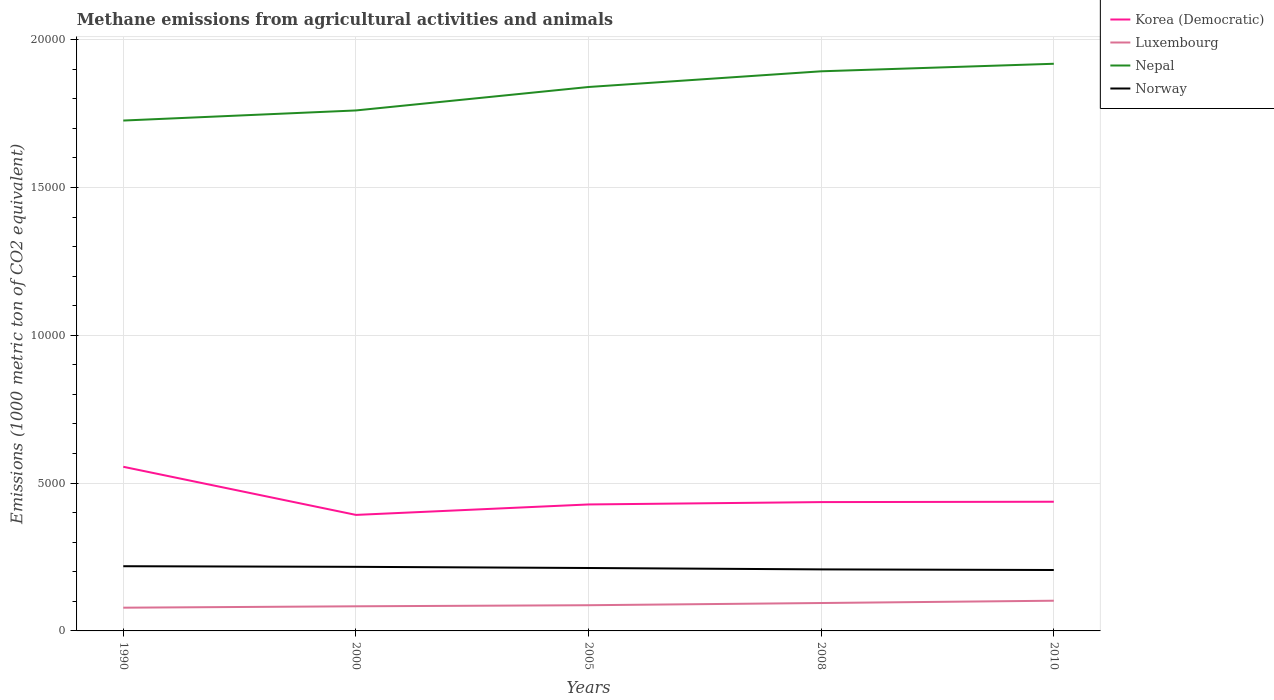Is the number of lines equal to the number of legend labels?
Provide a short and direct response. Yes. Across all years, what is the maximum amount of methane emitted in Norway?
Your answer should be compact. 2060.5. In which year was the amount of methane emitted in Nepal maximum?
Your response must be concise. 1990. What is the total amount of methane emitted in Norway in the graph?
Offer a very short reply. 39.3. What is the difference between the highest and the second highest amount of methane emitted in Norway?
Provide a short and direct response. 128. Is the amount of methane emitted in Luxembourg strictly greater than the amount of methane emitted in Nepal over the years?
Offer a terse response. Yes. What is the difference between two consecutive major ticks on the Y-axis?
Ensure brevity in your answer.  5000. Does the graph contain grids?
Provide a short and direct response. Yes. Where does the legend appear in the graph?
Your response must be concise. Top right. How are the legend labels stacked?
Provide a succinct answer. Vertical. What is the title of the graph?
Your answer should be very brief. Methane emissions from agricultural activities and animals. What is the label or title of the X-axis?
Offer a terse response. Years. What is the label or title of the Y-axis?
Provide a short and direct response. Emissions (1000 metric ton of CO2 equivalent). What is the Emissions (1000 metric ton of CO2 equivalent) of Korea (Democratic) in 1990?
Offer a terse response. 5552.4. What is the Emissions (1000 metric ton of CO2 equivalent) in Luxembourg in 1990?
Make the answer very short. 785.7. What is the Emissions (1000 metric ton of CO2 equivalent) in Nepal in 1990?
Provide a short and direct response. 1.73e+04. What is the Emissions (1000 metric ton of CO2 equivalent) of Norway in 1990?
Your response must be concise. 2188.5. What is the Emissions (1000 metric ton of CO2 equivalent) in Korea (Democratic) in 2000?
Keep it short and to the point. 3924.5. What is the Emissions (1000 metric ton of CO2 equivalent) of Luxembourg in 2000?
Make the answer very short. 832.7. What is the Emissions (1000 metric ton of CO2 equivalent) of Nepal in 2000?
Offer a terse response. 1.76e+04. What is the Emissions (1000 metric ton of CO2 equivalent) in Norway in 2000?
Provide a short and direct response. 2167.9. What is the Emissions (1000 metric ton of CO2 equivalent) of Korea (Democratic) in 2005?
Your answer should be very brief. 4277.9. What is the Emissions (1000 metric ton of CO2 equivalent) of Luxembourg in 2005?
Provide a succinct answer. 869.4. What is the Emissions (1000 metric ton of CO2 equivalent) of Nepal in 2005?
Ensure brevity in your answer.  1.84e+04. What is the Emissions (1000 metric ton of CO2 equivalent) in Norway in 2005?
Offer a very short reply. 2128.6. What is the Emissions (1000 metric ton of CO2 equivalent) of Korea (Democratic) in 2008?
Give a very brief answer. 4357.8. What is the Emissions (1000 metric ton of CO2 equivalent) of Luxembourg in 2008?
Provide a short and direct response. 943.9. What is the Emissions (1000 metric ton of CO2 equivalent) in Nepal in 2008?
Your response must be concise. 1.89e+04. What is the Emissions (1000 metric ton of CO2 equivalent) of Norway in 2008?
Keep it short and to the point. 2081.3. What is the Emissions (1000 metric ton of CO2 equivalent) in Korea (Democratic) in 2010?
Provide a short and direct response. 4370.1. What is the Emissions (1000 metric ton of CO2 equivalent) in Luxembourg in 2010?
Your answer should be very brief. 1021.4. What is the Emissions (1000 metric ton of CO2 equivalent) of Nepal in 2010?
Your answer should be very brief. 1.92e+04. What is the Emissions (1000 metric ton of CO2 equivalent) of Norway in 2010?
Provide a short and direct response. 2060.5. Across all years, what is the maximum Emissions (1000 metric ton of CO2 equivalent) in Korea (Democratic)?
Provide a succinct answer. 5552.4. Across all years, what is the maximum Emissions (1000 metric ton of CO2 equivalent) of Luxembourg?
Offer a terse response. 1021.4. Across all years, what is the maximum Emissions (1000 metric ton of CO2 equivalent) of Nepal?
Ensure brevity in your answer.  1.92e+04. Across all years, what is the maximum Emissions (1000 metric ton of CO2 equivalent) of Norway?
Make the answer very short. 2188.5. Across all years, what is the minimum Emissions (1000 metric ton of CO2 equivalent) of Korea (Democratic)?
Keep it short and to the point. 3924.5. Across all years, what is the minimum Emissions (1000 metric ton of CO2 equivalent) of Luxembourg?
Make the answer very short. 785.7. Across all years, what is the minimum Emissions (1000 metric ton of CO2 equivalent) of Nepal?
Your answer should be very brief. 1.73e+04. Across all years, what is the minimum Emissions (1000 metric ton of CO2 equivalent) in Norway?
Offer a very short reply. 2060.5. What is the total Emissions (1000 metric ton of CO2 equivalent) in Korea (Democratic) in the graph?
Your answer should be very brief. 2.25e+04. What is the total Emissions (1000 metric ton of CO2 equivalent) in Luxembourg in the graph?
Provide a short and direct response. 4453.1. What is the total Emissions (1000 metric ton of CO2 equivalent) of Nepal in the graph?
Your answer should be very brief. 9.14e+04. What is the total Emissions (1000 metric ton of CO2 equivalent) of Norway in the graph?
Offer a very short reply. 1.06e+04. What is the difference between the Emissions (1000 metric ton of CO2 equivalent) of Korea (Democratic) in 1990 and that in 2000?
Offer a terse response. 1627.9. What is the difference between the Emissions (1000 metric ton of CO2 equivalent) in Luxembourg in 1990 and that in 2000?
Provide a short and direct response. -47. What is the difference between the Emissions (1000 metric ton of CO2 equivalent) in Nepal in 1990 and that in 2000?
Provide a short and direct response. -341.8. What is the difference between the Emissions (1000 metric ton of CO2 equivalent) in Norway in 1990 and that in 2000?
Offer a very short reply. 20.6. What is the difference between the Emissions (1000 metric ton of CO2 equivalent) in Korea (Democratic) in 1990 and that in 2005?
Offer a terse response. 1274.5. What is the difference between the Emissions (1000 metric ton of CO2 equivalent) in Luxembourg in 1990 and that in 2005?
Offer a terse response. -83.7. What is the difference between the Emissions (1000 metric ton of CO2 equivalent) of Nepal in 1990 and that in 2005?
Provide a short and direct response. -1135.1. What is the difference between the Emissions (1000 metric ton of CO2 equivalent) of Norway in 1990 and that in 2005?
Your answer should be very brief. 59.9. What is the difference between the Emissions (1000 metric ton of CO2 equivalent) of Korea (Democratic) in 1990 and that in 2008?
Offer a very short reply. 1194.6. What is the difference between the Emissions (1000 metric ton of CO2 equivalent) of Luxembourg in 1990 and that in 2008?
Ensure brevity in your answer.  -158.2. What is the difference between the Emissions (1000 metric ton of CO2 equivalent) in Nepal in 1990 and that in 2008?
Provide a short and direct response. -1666.2. What is the difference between the Emissions (1000 metric ton of CO2 equivalent) of Norway in 1990 and that in 2008?
Offer a terse response. 107.2. What is the difference between the Emissions (1000 metric ton of CO2 equivalent) of Korea (Democratic) in 1990 and that in 2010?
Make the answer very short. 1182.3. What is the difference between the Emissions (1000 metric ton of CO2 equivalent) in Luxembourg in 1990 and that in 2010?
Ensure brevity in your answer.  -235.7. What is the difference between the Emissions (1000 metric ton of CO2 equivalent) in Nepal in 1990 and that in 2010?
Your response must be concise. -1920.6. What is the difference between the Emissions (1000 metric ton of CO2 equivalent) of Norway in 1990 and that in 2010?
Offer a very short reply. 128. What is the difference between the Emissions (1000 metric ton of CO2 equivalent) in Korea (Democratic) in 2000 and that in 2005?
Give a very brief answer. -353.4. What is the difference between the Emissions (1000 metric ton of CO2 equivalent) of Luxembourg in 2000 and that in 2005?
Your response must be concise. -36.7. What is the difference between the Emissions (1000 metric ton of CO2 equivalent) of Nepal in 2000 and that in 2005?
Provide a short and direct response. -793.3. What is the difference between the Emissions (1000 metric ton of CO2 equivalent) of Norway in 2000 and that in 2005?
Offer a terse response. 39.3. What is the difference between the Emissions (1000 metric ton of CO2 equivalent) in Korea (Democratic) in 2000 and that in 2008?
Ensure brevity in your answer.  -433.3. What is the difference between the Emissions (1000 metric ton of CO2 equivalent) in Luxembourg in 2000 and that in 2008?
Your answer should be very brief. -111.2. What is the difference between the Emissions (1000 metric ton of CO2 equivalent) in Nepal in 2000 and that in 2008?
Your response must be concise. -1324.4. What is the difference between the Emissions (1000 metric ton of CO2 equivalent) in Norway in 2000 and that in 2008?
Provide a short and direct response. 86.6. What is the difference between the Emissions (1000 metric ton of CO2 equivalent) in Korea (Democratic) in 2000 and that in 2010?
Ensure brevity in your answer.  -445.6. What is the difference between the Emissions (1000 metric ton of CO2 equivalent) in Luxembourg in 2000 and that in 2010?
Offer a very short reply. -188.7. What is the difference between the Emissions (1000 metric ton of CO2 equivalent) of Nepal in 2000 and that in 2010?
Provide a short and direct response. -1578.8. What is the difference between the Emissions (1000 metric ton of CO2 equivalent) in Norway in 2000 and that in 2010?
Make the answer very short. 107.4. What is the difference between the Emissions (1000 metric ton of CO2 equivalent) of Korea (Democratic) in 2005 and that in 2008?
Your answer should be compact. -79.9. What is the difference between the Emissions (1000 metric ton of CO2 equivalent) in Luxembourg in 2005 and that in 2008?
Keep it short and to the point. -74.5. What is the difference between the Emissions (1000 metric ton of CO2 equivalent) in Nepal in 2005 and that in 2008?
Offer a terse response. -531.1. What is the difference between the Emissions (1000 metric ton of CO2 equivalent) in Norway in 2005 and that in 2008?
Provide a short and direct response. 47.3. What is the difference between the Emissions (1000 metric ton of CO2 equivalent) in Korea (Democratic) in 2005 and that in 2010?
Offer a very short reply. -92.2. What is the difference between the Emissions (1000 metric ton of CO2 equivalent) in Luxembourg in 2005 and that in 2010?
Your response must be concise. -152. What is the difference between the Emissions (1000 metric ton of CO2 equivalent) in Nepal in 2005 and that in 2010?
Provide a succinct answer. -785.5. What is the difference between the Emissions (1000 metric ton of CO2 equivalent) of Norway in 2005 and that in 2010?
Offer a very short reply. 68.1. What is the difference between the Emissions (1000 metric ton of CO2 equivalent) of Luxembourg in 2008 and that in 2010?
Offer a very short reply. -77.5. What is the difference between the Emissions (1000 metric ton of CO2 equivalent) in Nepal in 2008 and that in 2010?
Give a very brief answer. -254.4. What is the difference between the Emissions (1000 metric ton of CO2 equivalent) in Norway in 2008 and that in 2010?
Your answer should be compact. 20.8. What is the difference between the Emissions (1000 metric ton of CO2 equivalent) of Korea (Democratic) in 1990 and the Emissions (1000 metric ton of CO2 equivalent) of Luxembourg in 2000?
Keep it short and to the point. 4719.7. What is the difference between the Emissions (1000 metric ton of CO2 equivalent) in Korea (Democratic) in 1990 and the Emissions (1000 metric ton of CO2 equivalent) in Nepal in 2000?
Your answer should be compact. -1.21e+04. What is the difference between the Emissions (1000 metric ton of CO2 equivalent) of Korea (Democratic) in 1990 and the Emissions (1000 metric ton of CO2 equivalent) of Norway in 2000?
Make the answer very short. 3384.5. What is the difference between the Emissions (1000 metric ton of CO2 equivalent) in Luxembourg in 1990 and the Emissions (1000 metric ton of CO2 equivalent) in Nepal in 2000?
Make the answer very short. -1.68e+04. What is the difference between the Emissions (1000 metric ton of CO2 equivalent) of Luxembourg in 1990 and the Emissions (1000 metric ton of CO2 equivalent) of Norway in 2000?
Offer a very short reply. -1382.2. What is the difference between the Emissions (1000 metric ton of CO2 equivalent) in Nepal in 1990 and the Emissions (1000 metric ton of CO2 equivalent) in Norway in 2000?
Offer a very short reply. 1.51e+04. What is the difference between the Emissions (1000 metric ton of CO2 equivalent) in Korea (Democratic) in 1990 and the Emissions (1000 metric ton of CO2 equivalent) in Luxembourg in 2005?
Ensure brevity in your answer.  4683. What is the difference between the Emissions (1000 metric ton of CO2 equivalent) in Korea (Democratic) in 1990 and the Emissions (1000 metric ton of CO2 equivalent) in Nepal in 2005?
Your response must be concise. -1.28e+04. What is the difference between the Emissions (1000 metric ton of CO2 equivalent) in Korea (Democratic) in 1990 and the Emissions (1000 metric ton of CO2 equivalent) in Norway in 2005?
Your answer should be very brief. 3423.8. What is the difference between the Emissions (1000 metric ton of CO2 equivalent) of Luxembourg in 1990 and the Emissions (1000 metric ton of CO2 equivalent) of Nepal in 2005?
Your answer should be compact. -1.76e+04. What is the difference between the Emissions (1000 metric ton of CO2 equivalent) in Luxembourg in 1990 and the Emissions (1000 metric ton of CO2 equivalent) in Norway in 2005?
Your response must be concise. -1342.9. What is the difference between the Emissions (1000 metric ton of CO2 equivalent) of Nepal in 1990 and the Emissions (1000 metric ton of CO2 equivalent) of Norway in 2005?
Your response must be concise. 1.51e+04. What is the difference between the Emissions (1000 metric ton of CO2 equivalent) of Korea (Democratic) in 1990 and the Emissions (1000 metric ton of CO2 equivalent) of Luxembourg in 2008?
Provide a succinct answer. 4608.5. What is the difference between the Emissions (1000 metric ton of CO2 equivalent) in Korea (Democratic) in 1990 and the Emissions (1000 metric ton of CO2 equivalent) in Nepal in 2008?
Make the answer very short. -1.34e+04. What is the difference between the Emissions (1000 metric ton of CO2 equivalent) of Korea (Democratic) in 1990 and the Emissions (1000 metric ton of CO2 equivalent) of Norway in 2008?
Offer a terse response. 3471.1. What is the difference between the Emissions (1000 metric ton of CO2 equivalent) in Luxembourg in 1990 and the Emissions (1000 metric ton of CO2 equivalent) in Nepal in 2008?
Provide a short and direct response. -1.81e+04. What is the difference between the Emissions (1000 metric ton of CO2 equivalent) in Luxembourg in 1990 and the Emissions (1000 metric ton of CO2 equivalent) in Norway in 2008?
Your answer should be very brief. -1295.6. What is the difference between the Emissions (1000 metric ton of CO2 equivalent) of Nepal in 1990 and the Emissions (1000 metric ton of CO2 equivalent) of Norway in 2008?
Make the answer very short. 1.52e+04. What is the difference between the Emissions (1000 metric ton of CO2 equivalent) of Korea (Democratic) in 1990 and the Emissions (1000 metric ton of CO2 equivalent) of Luxembourg in 2010?
Keep it short and to the point. 4531. What is the difference between the Emissions (1000 metric ton of CO2 equivalent) in Korea (Democratic) in 1990 and the Emissions (1000 metric ton of CO2 equivalent) in Nepal in 2010?
Offer a very short reply. -1.36e+04. What is the difference between the Emissions (1000 metric ton of CO2 equivalent) of Korea (Democratic) in 1990 and the Emissions (1000 metric ton of CO2 equivalent) of Norway in 2010?
Ensure brevity in your answer.  3491.9. What is the difference between the Emissions (1000 metric ton of CO2 equivalent) of Luxembourg in 1990 and the Emissions (1000 metric ton of CO2 equivalent) of Nepal in 2010?
Provide a succinct answer. -1.84e+04. What is the difference between the Emissions (1000 metric ton of CO2 equivalent) of Luxembourg in 1990 and the Emissions (1000 metric ton of CO2 equivalent) of Norway in 2010?
Offer a terse response. -1274.8. What is the difference between the Emissions (1000 metric ton of CO2 equivalent) of Nepal in 1990 and the Emissions (1000 metric ton of CO2 equivalent) of Norway in 2010?
Give a very brief answer. 1.52e+04. What is the difference between the Emissions (1000 metric ton of CO2 equivalent) in Korea (Democratic) in 2000 and the Emissions (1000 metric ton of CO2 equivalent) in Luxembourg in 2005?
Your answer should be compact. 3055.1. What is the difference between the Emissions (1000 metric ton of CO2 equivalent) of Korea (Democratic) in 2000 and the Emissions (1000 metric ton of CO2 equivalent) of Nepal in 2005?
Make the answer very short. -1.45e+04. What is the difference between the Emissions (1000 metric ton of CO2 equivalent) in Korea (Democratic) in 2000 and the Emissions (1000 metric ton of CO2 equivalent) in Norway in 2005?
Your response must be concise. 1795.9. What is the difference between the Emissions (1000 metric ton of CO2 equivalent) in Luxembourg in 2000 and the Emissions (1000 metric ton of CO2 equivalent) in Nepal in 2005?
Your answer should be compact. -1.76e+04. What is the difference between the Emissions (1000 metric ton of CO2 equivalent) of Luxembourg in 2000 and the Emissions (1000 metric ton of CO2 equivalent) of Norway in 2005?
Your answer should be very brief. -1295.9. What is the difference between the Emissions (1000 metric ton of CO2 equivalent) in Nepal in 2000 and the Emissions (1000 metric ton of CO2 equivalent) in Norway in 2005?
Offer a very short reply. 1.55e+04. What is the difference between the Emissions (1000 metric ton of CO2 equivalent) of Korea (Democratic) in 2000 and the Emissions (1000 metric ton of CO2 equivalent) of Luxembourg in 2008?
Ensure brevity in your answer.  2980.6. What is the difference between the Emissions (1000 metric ton of CO2 equivalent) of Korea (Democratic) in 2000 and the Emissions (1000 metric ton of CO2 equivalent) of Nepal in 2008?
Your answer should be compact. -1.50e+04. What is the difference between the Emissions (1000 metric ton of CO2 equivalent) of Korea (Democratic) in 2000 and the Emissions (1000 metric ton of CO2 equivalent) of Norway in 2008?
Offer a terse response. 1843.2. What is the difference between the Emissions (1000 metric ton of CO2 equivalent) in Luxembourg in 2000 and the Emissions (1000 metric ton of CO2 equivalent) in Nepal in 2008?
Give a very brief answer. -1.81e+04. What is the difference between the Emissions (1000 metric ton of CO2 equivalent) in Luxembourg in 2000 and the Emissions (1000 metric ton of CO2 equivalent) in Norway in 2008?
Offer a terse response. -1248.6. What is the difference between the Emissions (1000 metric ton of CO2 equivalent) in Nepal in 2000 and the Emissions (1000 metric ton of CO2 equivalent) in Norway in 2008?
Keep it short and to the point. 1.55e+04. What is the difference between the Emissions (1000 metric ton of CO2 equivalent) in Korea (Democratic) in 2000 and the Emissions (1000 metric ton of CO2 equivalent) in Luxembourg in 2010?
Provide a succinct answer. 2903.1. What is the difference between the Emissions (1000 metric ton of CO2 equivalent) in Korea (Democratic) in 2000 and the Emissions (1000 metric ton of CO2 equivalent) in Nepal in 2010?
Keep it short and to the point. -1.53e+04. What is the difference between the Emissions (1000 metric ton of CO2 equivalent) in Korea (Democratic) in 2000 and the Emissions (1000 metric ton of CO2 equivalent) in Norway in 2010?
Offer a terse response. 1864. What is the difference between the Emissions (1000 metric ton of CO2 equivalent) in Luxembourg in 2000 and the Emissions (1000 metric ton of CO2 equivalent) in Nepal in 2010?
Offer a terse response. -1.84e+04. What is the difference between the Emissions (1000 metric ton of CO2 equivalent) in Luxembourg in 2000 and the Emissions (1000 metric ton of CO2 equivalent) in Norway in 2010?
Provide a short and direct response. -1227.8. What is the difference between the Emissions (1000 metric ton of CO2 equivalent) of Nepal in 2000 and the Emissions (1000 metric ton of CO2 equivalent) of Norway in 2010?
Offer a very short reply. 1.55e+04. What is the difference between the Emissions (1000 metric ton of CO2 equivalent) in Korea (Democratic) in 2005 and the Emissions (1000 metric ton of CO2 equivalent) in Luxembourg in 2008?
Your response must be concise. 3334. What is the difference between the Emissions (1000 metric ton of CO2 equivalent) in Korea (Democratic) in 2005 and the Emissions (1000 metric ton of CO2 equivalent) in Nepal in 2008?
Provide a short and direct response. -1.47e+04. What is the difference between the Emissions (1000 metric ton of CO2 equivalent) in Korea (Democratic) in 2005 and the Emissions (1000 metric ton of CO2 equivalent) in Norway in 2008?
Your answer should be very brief. 2196.6. What is the difference between the Emissions (1000 metric ton of CO2 equivalent) of Luxembourg in 2005 and the Emissions (1000 metric ton of CO2 equivalent) of Nepal in 2008?
Your response must be concise. -1.81e+04. What is the difference between the Emissions (1000 metric ton of CO2 equivalent) in Luxembourg in 2005 and the Emissions (1000 metric ton of CO2 equivalent) in Norway in 2008?
Your response must be concise. -1211.9. What is the difference between the Emissions (1000 metric ton of CO2 equivalent) in Nepal in 2005 and the Emissions (1000 metric ton of CO2 equivalent) in Norway in 2008?
Provide a succinct answer. 1.63e+04. What is the difference between the Emissions (1000 metric ton of CO2 equivalent) in Korea (Democratic) in 2005 and the Emissions (1000 metric ton of CO2 equivalent) in Luxembourg in 2010?
Give a very brief answer. 3256.5. What is the difference between the Emissions (1000 metric ton of CO2 equivalent) in Korea (Democratic) in 2005 and the Emissions (1000 metric ton of CO2 equivalent) in Nepal in 2010?
Your response must be concise. -1.49e+04. What is the difference between the Emissions (1000 metric ton of CO2 equivalent) of Korea (Democratic) in 2005 and the Emissions (1000 metric ton of CO2 equivalent) of Norway in 2010?
Offer a very short reply. 2217.4. What is the difference between the Emissions (1000 metric ton of CO2 equivalent) in Luxembourg in 2005 and the Emissions (1000 metric ton of CO2 equivalent) in Nepal in 2010?
Offer a terse response. -1.83e+04. What is the difference between the Emissions (1000 metric ton of CO2 equivalent) of Luxembourg in 2005 and the Emissions (1000 metric ton of CO2 equivalent) of Norway in 2010?
Your answer should be compact. -1191.1. What is the difference between the Emissions (1000 metric ton of CO2 equivalent) of Nepal in 2005 and the Emissions (1000 metric ton of CO2 equivalent) of Norway in 2010?
Keep it short and to the point. 1.63e+04. What is the difference between the Emissions (1000 metric ton of CO2 equivalent) of Korea (Democratic) in 2008 and the Emissions (1000 metric ton of CO2 equivalent) of Luxembourg in 2010?
Offer a terse response. 3336.4. What is the difference between the Emissions (1000 metric ton of CO2 equivalent) in Korea (Democratic) in 2008 and the Emissions (1000 metric ton of CO2 equivalent) in Nepal in 2010?
Provide a succinct answer. -1.48e+04. What is the difference between the Emissions (1000 metric ton of CO2 equivalent) in Korea (Democratic) in 2008 and the Emissions (1000 metric ton of CO2 equivalent) in Norway in 2010?
Keep it short and to the point. 2297.3. What is the difference between the Emissions (1000 metric ton of CO2 equivalent) in Luxembourg in 2008 and the Emissions (1000 metric ton of CO2 equivalent) in Nepal in 2010?
Offer a very short reply. -1.82e+04. What is the difference between the Emissions (1000 metric ton of CO2 equivalent) in Luxembourg in 2008 and the Emissions (1000 metric ton of CO2 equivalent) in Norway in 2010?
Provide a succinct answer. -1116.6. What is the difference between the Emissions (1000 metric ton of CO2 equivalent) in Nepal in 2008 and the Emissions (1000 metric ton of CO2 equivalent) in Norway in 2010?
Your response must be concise. 1.69e+04. What is the average Emissions (1000 metric ton of CO2 equivalent) in Korea (Democratic) per year?
Keep it short and to the point. 4496.54. What is the average Emissions (1000 metric ton of CO2 equivalent) in Luxembourg per year?
Your answer should be very brief. 890.62. What is the average Emissions (1000 metric ton of CO2 equivalent) of Nepal per year?
Your answer should be compact. 1.83e+04. What is the average Emissions (1000 metric ton of CO2 equivalent) in Norway per year?
Keep it short and to the point. 2125.36. In the year 1990, what is the difference between the Emissions (1000 metric ton of CO2 equivalent) in Korea (Democratic) and Emissions (1000 metric ton of CO2 equivalent) in Luxembourg?
Your answer should be very brief. 4766.7. In the year 1990, what is the difference between the Emissions (1000 metric ton of CO2 equivalent) of Korea (Democratic) and Emissions (1000 metric ton of CO2 equivalent) of Nepal?
Your response must be concise. -1.17e+04. In the year 1990, what is the difference between the Emissions (1000 metric ton of CO2 equivalent) in Korea (Democratic) and Emissions (1000 metric ton of CO2 equivalent) in Norway?
Offer a very short reply. 3363.9. In the year 1990, what is the difference between the Emissions (1000 metric ton of CO2 equivalent) in Luxembourg and Emissions (1000 metric ton of CO2 equivalent) in Nepal?
Keep it short and to the point. -1.65e+04. In the year 1990, what is the difference between the Emissions (1000 metric ton of CO2 equivalent) of Luxembourg and Emissions (1000 metric ton of CO2 equivalent) of Norway?
Offer a terse response. -1402.8. In the year 1990, what is the difference between the Emissions (1000 metric ton of CO2 equivalent) in Nepal and Emissions (1000 metric ton of CO2 equivalent) in Norway?
Make the answer very short. 1.51e+04. In the year 2000, what is the difference between the Emissions (1000 metric ton of CO2 equivalent) in Korea (Democratic) and Emissions (1000 metric ton of CO2 equivalent) in Luxembourg?
Your answer should be compact. 3091.8. In the year 2000, what is the difference between the Emissions (1000 metric ton of CO2 equivalent) of Korea (Democratic) and Emissions (1000 metric ton of CO2 equivalent) of Nepal?
Make the answer very short. -1.37e+04. In the year 2000, what is the difference between the Emissions (1000 metric ton of CO2 equivalent) in Korea (Democratic) and Emissions (1000 metric ton of CO2 equivalent) in Norway?
Offer a terse response. 1756.6. In the year 2000, what is the difference between the Emissions (1000 metric ton of CO2 equivalent) of Luxembourg and Emissions (1000 metric ton of CO2 equivalent) of Nepal?
Provide a succinct answer. -1.68e+04. In the year 2000, what is the difference between the Emissions (1000 metric ton of CO2 equivalent) of Luxembourg and Emissions (1000 metric ton of CO2 equivalent) of Norway?
Ensure brevity in your answer.  -1335.2. In the year 2000, what is the difference between the Emissions (1000 metric ton of CO2 equivalent) in Nepal and Emissions (1000 metric ton of CO2 equivalent) in Norway?
Give a very brief answer. 1.54e+04. In the year 2005, what is the difference between the Emissions (1000 metric ton of CO2 equivalent) in Korea (Democratic) and Emissions (1000 metric ton of CO2 equivalent) in Luxembourg?
Your response must be concise. 3408.5. In the year 2005, what is the difference between the Emissions (1000 metric ton of CO2 equivalent) in Korea (Democratic) and Emissions (1000 metric ton of CO2 equivalent) in Nepal?
Ensure brevity in your answer.  -1.41e+04. In the year 2005, what is the difference between the Emissions (1000 metric ton of CO2 equivalent) in Korea (Democratic) and Emissions (1000 metric ton of CO2 equivalent) in Norway?
Your response must be concise. 2149.3. In the year 2005, what is the difference between the Emissions (1000 metric ton of CO2 equivalent) in Luxembourg and Emissions (1000 metric ton of CO2 equivalent) in Nepal?
Provide a succinct answer. -1.75e+04. In the year 2005, what is the difference between the Emissions (1000 metric ton of CO2 equivalent) in Luxembourg and Emissions (1000 metric ton of CO2 equivalent) in Norway?
Keep it short and to the point. -1259.2. In the year 2005, what is the difference between the Emissions (1000 metric ton of CO2 equivalent) in Nepal and Emissions (1000 metric ton of CO2 equivalent) in Norway?
Keep it short and to the point. 1.63e+04. In the year 2008, what is the difference between the Emissions (1000 metric ton of CO2 equivalent) in Korea (Democratic) and Emissions (1000 metric ton of CO2 equivalent) in Luxembourg?
Your response must be concise. 3413.9. In the year 2008, what is the difference between the Emissions (1000 metric ton of CO2 equivalent) in Korea (Democratic) and Emissions (1000 metric ton of CO2 equivalent) in Nepal?
Give a very brief answer. -1.46e+04. In the year 2008, what is the difference between the Emissions (1000 metric ton of CO2 equivalent) of Korea (Democratic) and Emissions (1000 metric ton of CO2 equivalent) of Norway?
Offer a terse response. 2276.5. In the year 2008, what is the difference between the Emissions (1000 metric ton of CO2 equivalent) in Luxembourg and Emissions (1000 metric ton of CO2 equivalent) in Nepal?
Ensure brevity in your answer.  -1.80e+04. In the year 2008, what is the difference between the Emissions (1000 metric ton of CO2 equivalent) in Luxembourg and Emissions (1000 metric ton of CO2 equivalent) in Norway?
Provide a succinct answer. -1137.4. In the year 2008, what is the difference between the Emissions (1000 metric ton of CO2 equivalent) in Nepal and Emissions (1000 metric ton of CO2 equivalent) in Norway?
Provide a short and direct response. 1.68e+04. In the year 2010, what is the difference between the Emissions (1000 metric ton of CO2 equivalent) in Korea (Democratic) and Emissions (1000 metric ton of CO2 equivalent) in Luxembourg?
Your answer should be compact. 3348.7. In the year 2010, what is the difference between the Emissions (1000 metric ton of CO2 equivalent) of Korea (Democratic) and Emissions (1000 metric ton of CO2 equivalent) of Nepal?
Offer a very short reply. -1.48e+04. In the year 2010, what is the difference between the Emissions (1000 metric ton of CO2 equivalent) of Korea (Democratic) and Emissions (1000 metric ton of CO2 equivalent) of Norway?
Ensure brevity in your answer.  2309.6. In the year 2010, what is the difference between the Emissions (1000 metric ton of CO2 equivalent) of Luxembourg and Emissions (1000 metric ton of CO2 equivalent) of Nepal?
Offer a very short reply. -1.82e+04. In the year 2010, what is the difference between the Emissions (1000 metric ton of CO2 equivalent) in Luxembourg and Emissions (1000 metric ton of CO2 equivalent) in Norway?
Your answer should be very brief. -1039.1. In the year 2010, what is the difference between the Emissions (1000 metric ton of CO2 equivalent) of Nepal and Emissions (1000 metric ton of CO2 equivalent) of Norway?
Offer a terse response. 1.71e+04. What is the ratio of the Emissions (1000 metric ton of CO2 equivalent) of Korea (Democratic) in 1990 to that in 2000?
Keep it short and to the point. 1.41. What is the ratio of the Emissions (1000 metric ton of CO2 equivalent) in Luxembourg in 1990 to that in 2000?
Your answer should be very brief. 0.94. What is the ratio of the Emissions (1000 metric ton of CO2 equivalent) of Nepal in 1990 to that in 2000?
Offer a terse response. 0.98. What is the ratio of the Emissions (1000 metric ton of CO2 equivalent) in Norway in 1990 to that in 2000?
Provide a succinct answer. 1.01. What is the ratio of the Emissions (1000 metric ton of CO2 equivalent) of Korea (Democratic) in 1990 to that in 2005?
Offer a very short reply. 1.3. What is the ratio of the Emissions (1000 metric ton of CO2 equivalent) of Luxembourg in 1990 to that in 2005?
Make the answer very short. 0.9. What is the ratio of the Emissions (1000 metric ton of CO2 equivalent) in Nepal in 1990 to that in 2005?
Offer a terse response. 0.94. What is the ratio of the Emissions (1000 metric ton of CO2 equivalent) of Norway in 1990 to that in 2005?
Your answer should be compact. 1.03. What is the ratio of the Emissions (1000 metric ton of CO2 equivalent) in Korea (Democratic) in 1990 to that in 2008?
Provide a succinct answer. 1.27. What is the ratio of the Emissions (1000 metric ton of CO2 equivalent) in Luxembourg in 1990 to that in 2008?
Your answer should be compact. 0.83. What is the ratio of the Emissions (1000 metric ton of CO2 equivalent) in Nepal in 1990 to that in 2008?
Give a very brief answer. 0.91. What is the ratio of the Emissions (1000 metric ton of CO2 equivalent) in Norway in 1990 to that in 2008?
Make the answer very short. 1.05. What is the ratio of the Emissions (1000 metric ton of CO2 equivalent) of Korea (Democratic) in 1990 to that in 2010?
Provide a succinct answer. 1.27. What is the ratio of the Emissions (1000 metric ton of CO2 equivalent) in Luxembourg in 1990 to that in 2010?
Ensure brevity in your answer.  0.77. What is the ratio of the Emissions (1000 metric ton of CO2 equivalent) of Nepal in 1990 to that in 2010?
Ensure brevity in your answer.  0.9. What is the ratio of the Emissions (1000 metric ton of CO2 equivalent) of Norway in 1990 to that in 2010?
Your answer should be compact. 1.06. What is the ratio of the Emissions (1000 metric ton of CO2 equivalent) in Korea (Democratic) in 2000 to that in 2005?
Your answer should be very brief. 0.92. What is the ratio of the Emissions (1000 metric ton of CO2 equivalent) of Luxembourg in 2000 to that in 2005?
Offer a very short reply. 0.96. What is the ratio of the Emissions (1000 metric ton of CO2 equivalent) of Nepal in 2000 to that in 2005?
Offer a very short reply. 0.96. What is the ratio of the Emissions (1000 metric ton of CO2 equivalent) of Norway in 2000 to that in 2005?
Offer a terse response. 1.02. What is the ratio of the Emissions (1000 metric ton of CO2 equivalent) of Korea (Democratic) in 2000 to that in 2008?
Your answer should be very brief. 0.9. What is the ratio of the Emissions (1000 metric ton of CO2 equivalent) of Luxembourg in 2000 to that in 2008?
Give a very brief answer. 0.88. What is the ratio of the Emissions (1000 metric ton of CO2 equivalent) of Norway in 2000 to that in 2008?
Make the answer very short. 1.04. What is the ratio of the Emissions (1000 metric ton of CO2 equivalent) of Korea (Democratic) in 2000 to that in 2010?
Give a very brief answer. 0.9. What is the ratio of the Emissions (1000 metric ton of CO2 equivalent) in Luxembourg in 2000 to that in 2010?
Your answer should be compact. 0.82. What is the ratio of the Emissions (1000 metric ton of CO2 equivalent) in Nepal in 2000 to that in 2010?
Make the answer very short. 0.92. What is the ratio of the Emissions (1000 metric ton of CO2 equivalent) of Norway in 2000 to that in 2010?
Make the answer very short. 1.05. What is the ratio of the Emissions (1000 metric ton of CO2 equivalent) in Korea (Democratic) in 2005 to that in 2008?
Provide a short and direct response. 0.98. What is the ratio of the Emissions (1000 metric ton of CO2 equivalent) in Luxembourg in 2005 to that in 2008?
Your answer should be compact. 0.92. What is the ratio of the Emissions (1000 metric ton of CO2 equivalent) of Nepal in 2005 to that in 2008?
Give a very brief answer. 0.97. What is the ratio of the Emissions (1000 metric ton of CO2 equivalent) in Norway in 2005 to that in 2008?
Provide a short and direct response. 1.02. What is the ratio of the Emissions (1000 metric ton of CO2 equivalent) of Korea (Democratic) in 2005 to that in 2010?
Your answer should be very brief. 0.98. What is the ratio of the Emissions (1000 metric ton of CO2 equivalent) in Luxembourg in 2005 to that in 2010?
Offer a very short reply. 0.85. What is the ratio of the Emissions (1000 metric ton of CO2 equivalent) of Nepal in 2005 to that in 2010?
Your answer should be compact. 0.96. What is the ratio of the Emissions (1000 metric ton of CO2 equivalent) of Norway in 2005 to that in 2010?
Provide a short and direct response. 1.03. What is the ratio of the Emissions (1000 metric ton of CO2 equivalent) of Luxembourg in 2008 to that in 2010?
Keep it short and to the point. 0.92. What is the ratio of the Emissions (1000 metric ton of CO2 equivalent) in Nepal in 2008 to that in 2010?
Ensure brevity in your answer.  0.99. What is the difference between the highest and the second highest Emissions (1000 metric ton of CO2 equivalent) of Korea (Democratic)?
Make the answer very short. 1182.3. What is the difference between the highest and the second highest Emissions (1000 metric ton of CO2 equivalent) in Luxembourg?
Your answer should be very brief. 77.5. What is the difference between the highest and the second highest Emissions (1000 metric ton of CO2 equivalent) of Nepal?
Your answer should be very brief. 254.4. What is the difference between the highest and the second highest Emissions (1000 metric ton of CO2 equivalent) of Norway?
Keep it short and to the point. 20.6. What is the difference between the highest and the lowest Emissions (1000 metric ton of CO2 equivalent) in Korea (Democratic)?
Make the answer very short. 1627.9. What is the difference between the highest and the lowest Emissions (1000 metric ton of CO2 equivalent) in Luxembourg?
Provide a succinct answer. 235.7. What is the difference between the highest and the lowest Emissions (1000 metric ton of CO2 equivalent) in Nepal?
Offer a terse response. 1920.6. What is the difference between the highest and the lowest Emissions (1000 metric ton of CO2 equivalent) in Norway?
Provide a short and direct response. 128. 